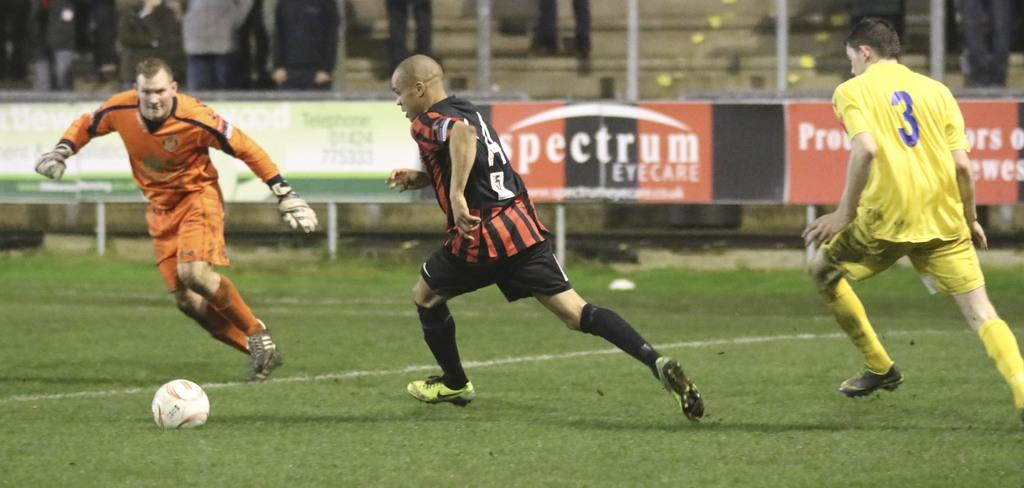<image>
Create a compact narrative representing the image presented. Soccer players on a field with advertisements that say spectrum EYECARE. 